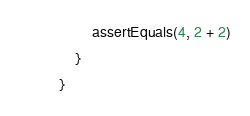Convert code to text. <code><loc_0><loc_0><loc_500><loc_500><_Kotlin_>        assertEquals(4, 2 + 2)
    }
}
</code> 